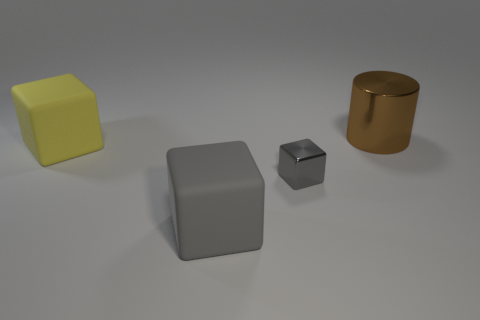Subtract all blue cubes. Subtract all blue cylinders. How many cubes are left? 3 Subtract all yellow balls. How many red cubes are left? 0 Add 2 grays. How many big browns exist? 0 Subtract all cyan things. Subtract all brown metal cylinders. How many objects are left? 3 Add 1 gray shiny things. How many gray shiny things are left? 2 Add 1 yellow shiny cylinders. How many yellow shiny cylinders exist? 1 Add 2 tiny gray matte balls. How many objects exist? 6 Subtract all gray blocks. How many blocks are left? 1 Subtract all gray rubber blocks. How many blocks are left? 2 Subtract 0 blue cylinders. How many objects are left? 4 